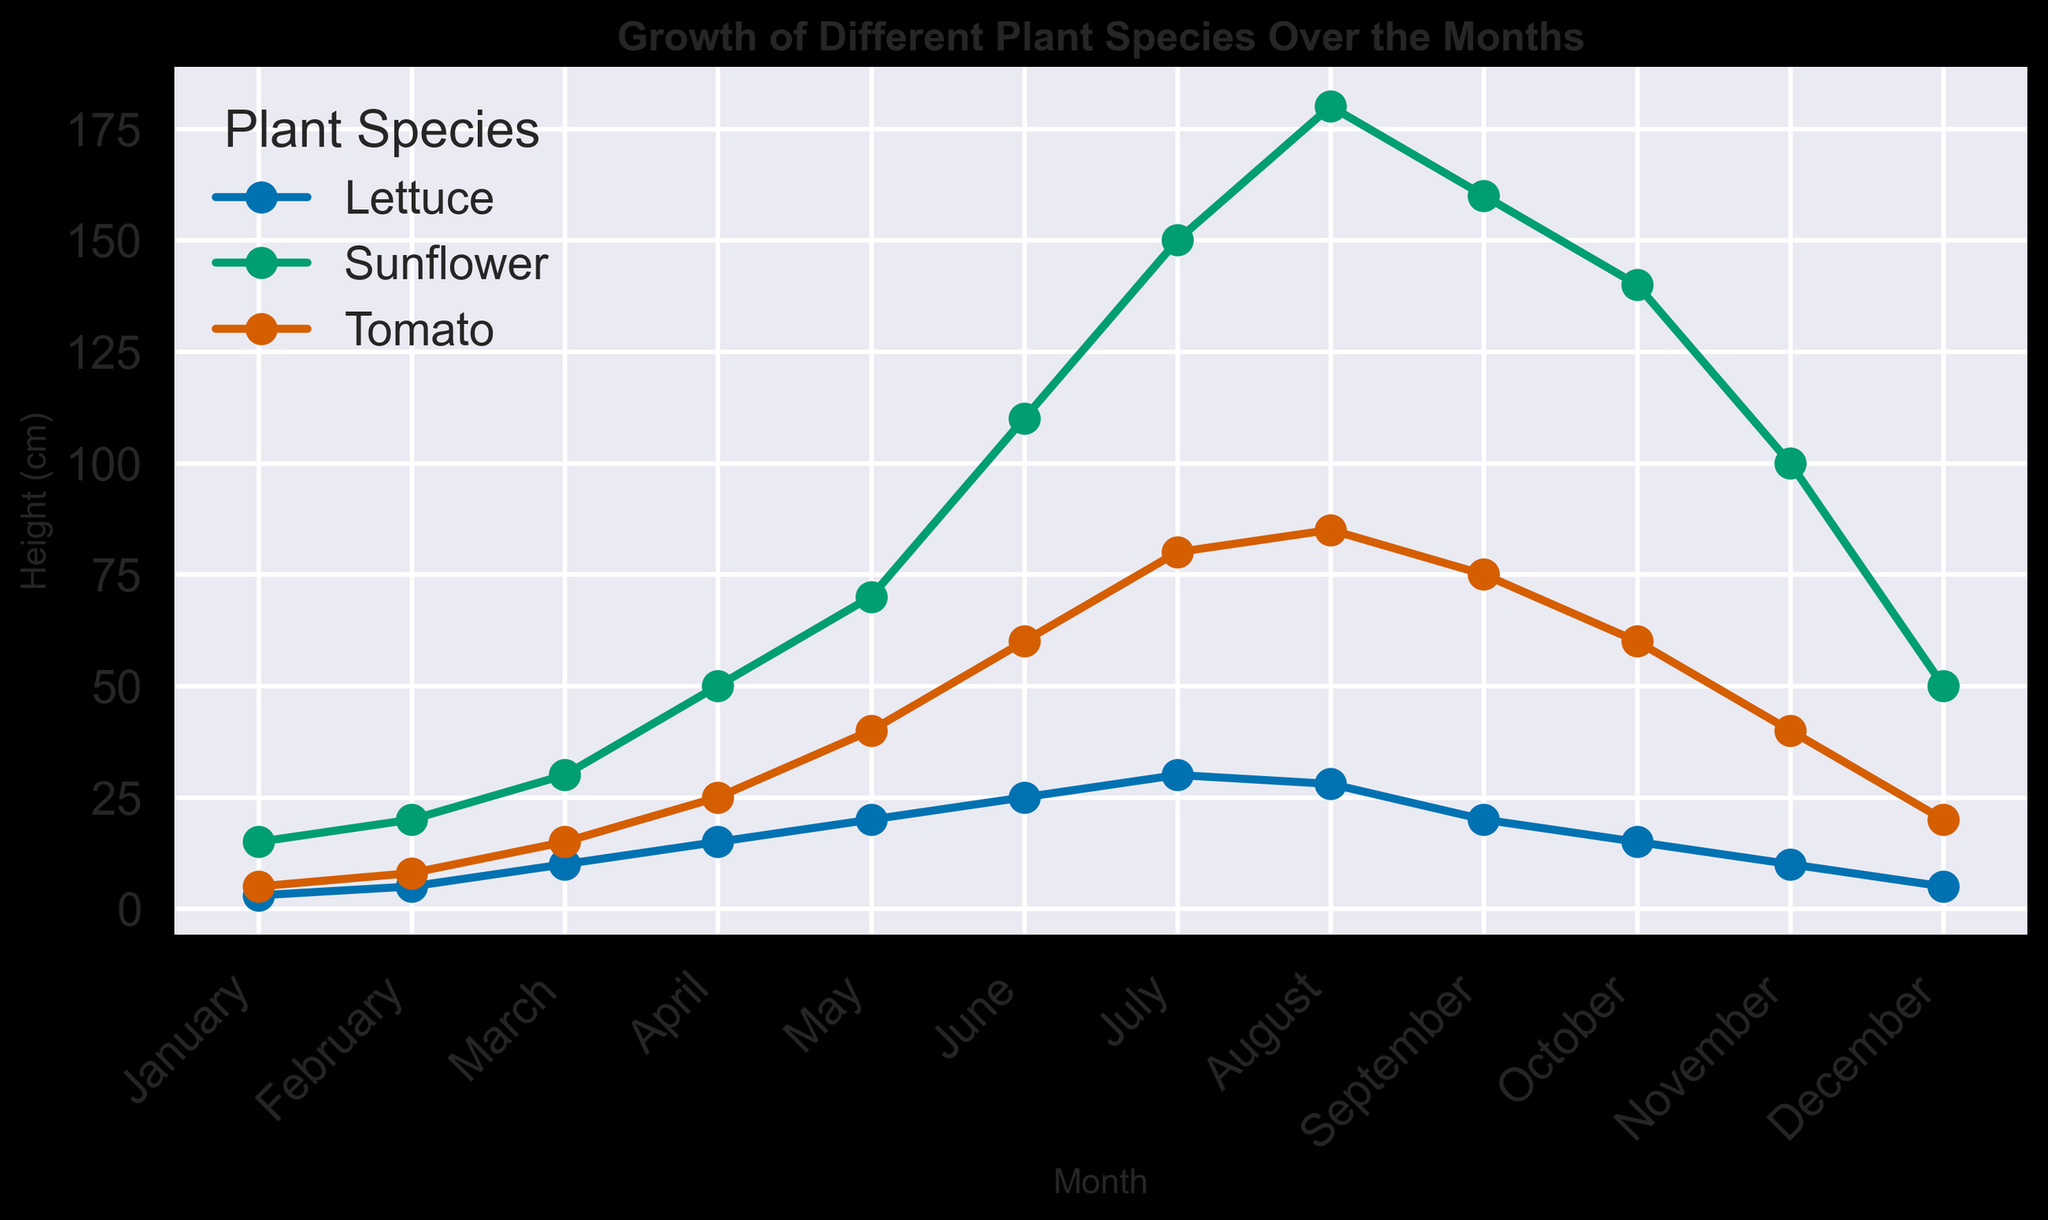What is the height of the Tomato plant in July? Locate the Tomato line (often identified by a specific color like red) and find the point corresponding to July. Observe the Y-axis value at this point.
Answer: 80 cm Which plant species shows the most rapid growth between March and June? Observe how steep the lines are between March and June for each plant. The steepest slope indicates the most rapid growth.
Answer: Sunflower By how much did the height of the Sunflower decrease from August to December? Note the height of the Sunflower in August (180 cm) and in December (50 cm). Calculate the difference: 180 - 50 = 130.
Answer: 130 cm Which plant species has the highest peak height, and in which month does this occur? Identify the highest point on each plant's line and compare them. The plant line reaching the highest value on the Y-axis holds the highest peak height. Note the corresponding month.
Answer: Sunflower, August Compare the heights of Lettuce in June and November. Which month has a greater height, and by how much? Check the heights where the Lettuce line intersects June (25 cm) and November (10 cm). Calculate the difference: 25 - 10 = 15.
Answer: June, by 15 cm What is the average height of the Tomato plant from January to December? Add the heights of the Tomato plant for all months and divide by 12. Heights are: 5, 8, 15, 25, 40, 60, 80, 85, 75, 60, 40, 20. (Total = 513, Average = 513/12)
Answer: 42.75 cm Which plant shows a decline in height after reaching its peak? Identify the plant with a line that descends after increasing to the highest point. Lookup the species and confirm the months of peak and decline.
Answer: Sunflower How many cm does the Lettuce grow from January to July? Take the Lettuce height in July (30 cm) and subtract the height in January (3 cm): 30 - 3 = 27.
Answer: 27 cm Between which two months does the Tomango plant show the largest increase in height? Find the steepest part of the Tomato line by comparing heights month-to-month. Observe mostly significant growth, specifically between which two months.
Answer: May to June What trend do you notice about all plants' heights in the latter half of the year (July to December)? Visually assess the trends for each plant from July to December. Observe if the lines generally increase, decrease, or stay the same.
Answer: They generally decrease in height 